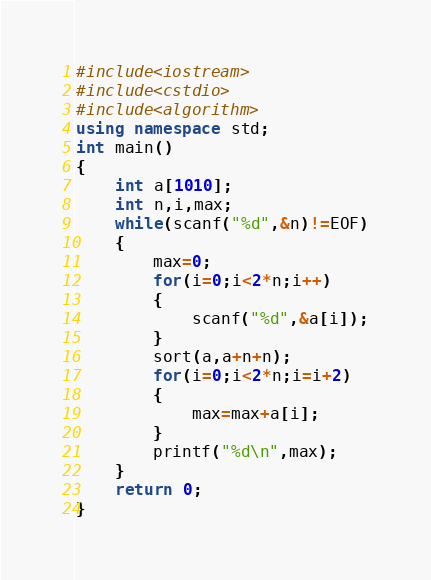<code> <loc_0><loc_0><loc_500><loc_500><_C++_>#include<iostream>
#include<cstdio>
#include<algorithm>
using namespace std;
int main()
{
	int a[1010];
	int n,i,max;
	while(scanf("%d",&n)!=EOF)
	{
		max=0;
		for(i=0;i<2*n;i++)
		{
			scanf("%d",&a[i]);
		}
		sort(a,a+n+n);
		for(i=0;i<2*n;i=i+2)
		{
			max=max+a[i];
		}
		printf("%d\n",max);
	}
	return 0;
}</code> 